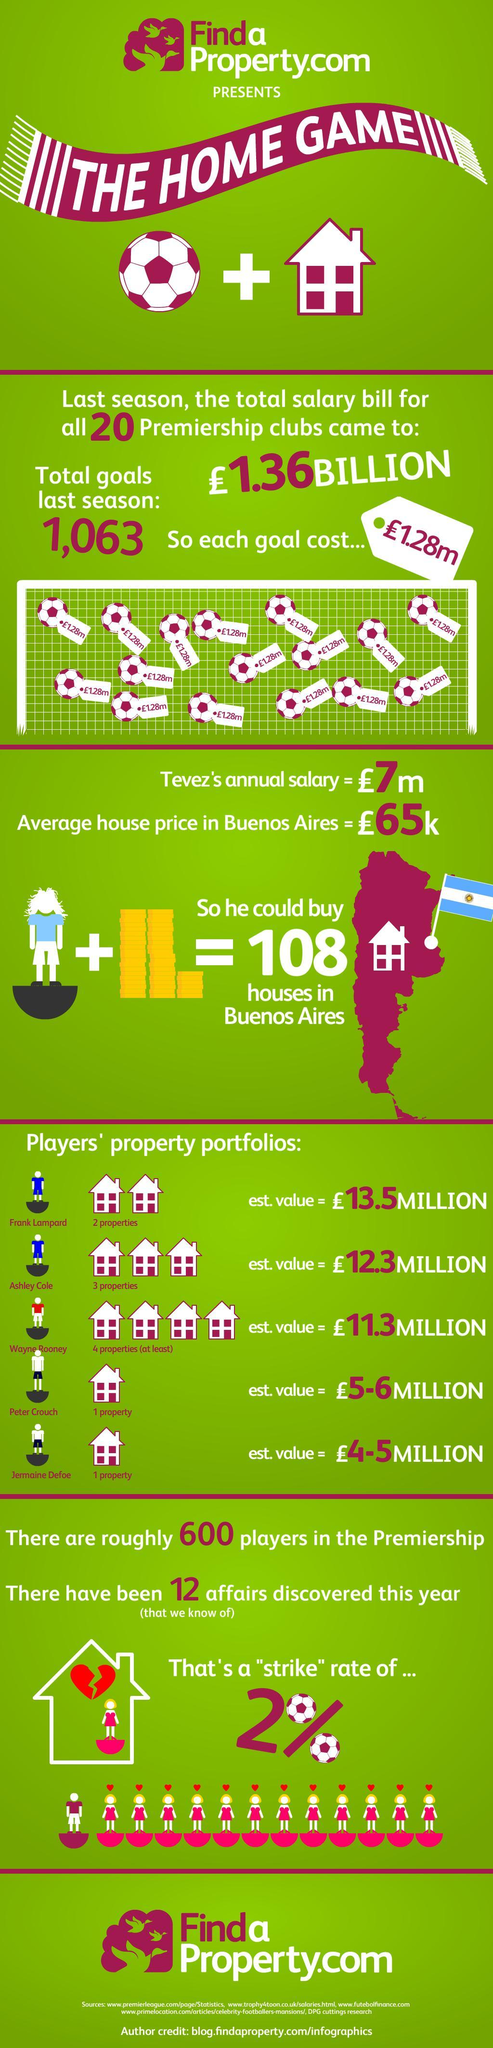What is the estimated cost in pounds of each goal?
Answer the question with a short phrase. 1.28m What is the average cost (in pounds) of buying a home in the capital of Argentina? 65k Which player listed in the graphic has most number of properties? Wayne Rooney How many goals were scored in total during previous season? 1,063 Which player's property has highest estimated value? Frank Lampard 